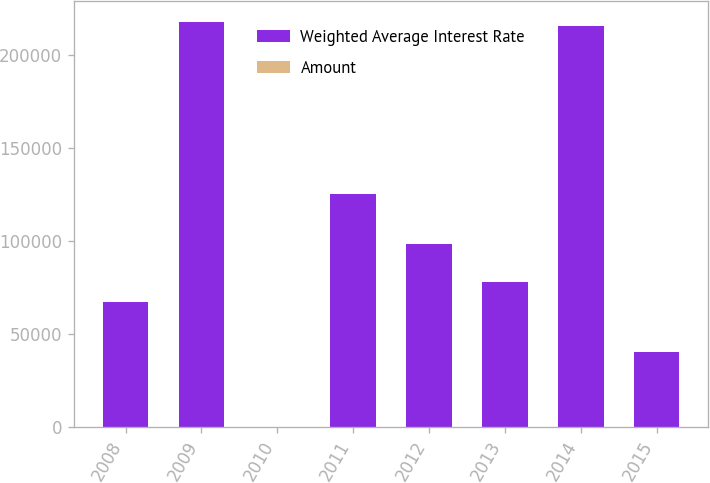<chart> <loc_0><loc_0><loc_500><loc_500><stacked_bar_chart><ecel><fcel>2008<fcel>2009<fcel>2010<fcel>2011<fcel>2012<fcel>2013<fcel>2014<fcel>2015<nl><fcel>Weighted Average Interest Rate<fcel>67233<fcel>217707<fcel>6.5<fcel>125292<fcel>98209<fcel>77674<fcel>215146<fcel>40590<nl><fcel>Amount<fcel>6.16<fcel>6<fcel>6.2<fcel>6.5<fcel>6.05<fcel>6.41<fcel>5.75<fcel>5.45<nl></chart> 